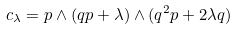<formula> <loc_0><loc_0><loc_500><loc_500>c _ { \lambda } = p \wedge ( q p + \lambda ) \wedge ( q ^ { 2 } p + 2 \lambda q )</formula> 